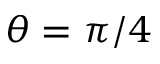<formula> <loc_0><loc_0><loc_500><loc_500>\theta = \pi / 4</formula> 